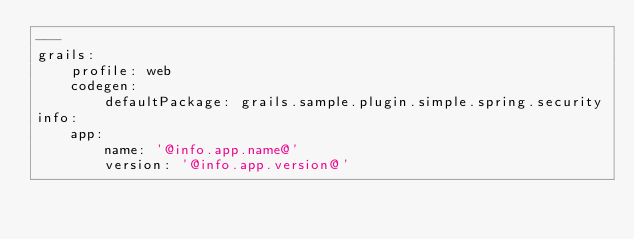<code> <loc_0><loc_0><loc_500><loc_500><_YAML_>---
grails:
    profile: web
    codegen:
        defaultPackage: grails.sample.plugin.simple.spring.security
info:
    app:
        name: '@info.app.name@'
        version: '@info.app.version@'</code> 